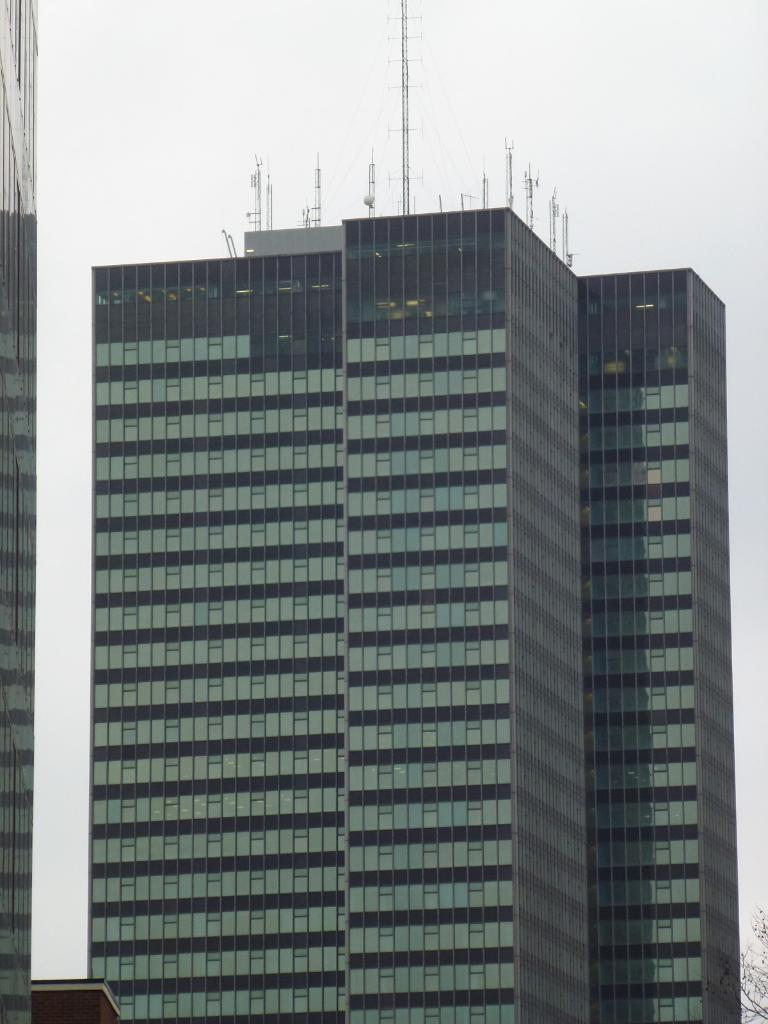What type of structures can be seen in the image? There are buildings in the image. What is visible at the top of the image? The sky is visible at the top of the image. How many teeth can be seen in the image? There are no teeth visible in the image; it features buildings and the sky. What type of basin is present in the image? There is no basin present in the image. 